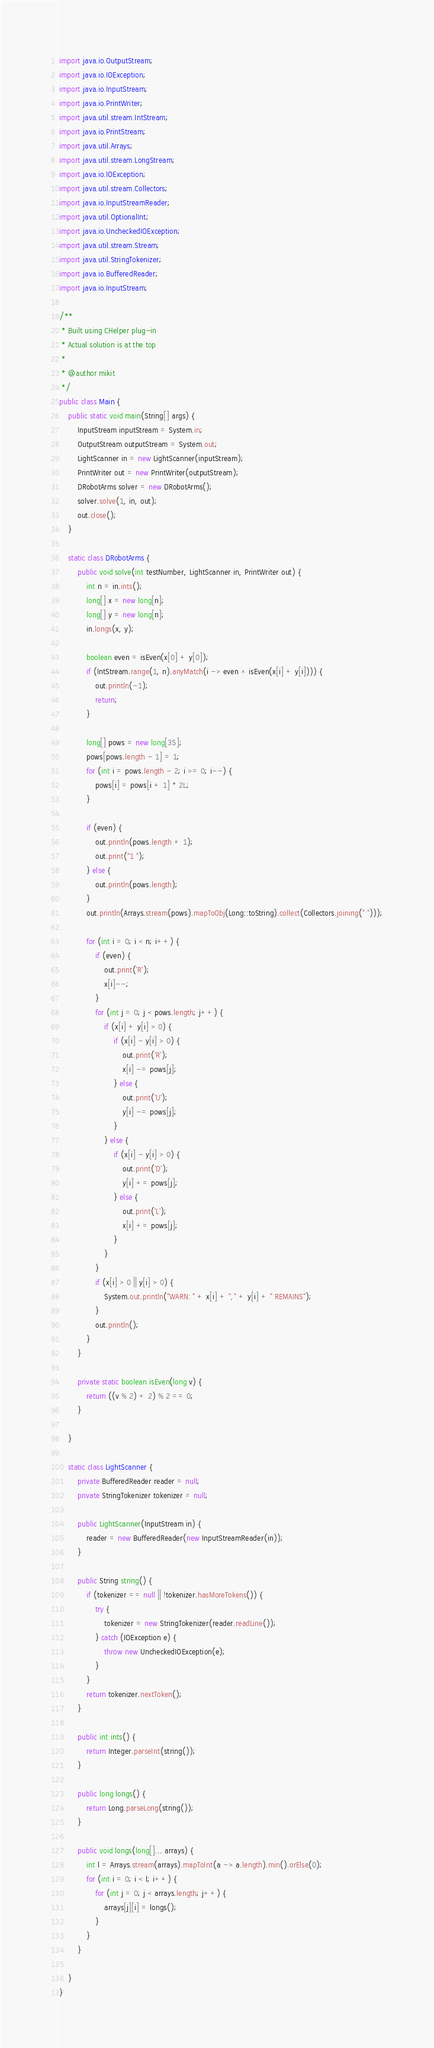<code> <loc_0><loc_0><loc_500><loc_500><_Java_>import java.io.OutputStream;
import java.io.IOException;
import java.io.InputStream;
import java.io.PrintWriter;
import java.util.stream.IntStream;
import java.io.PrintStream;
import java.util.Arrays;
import java.util.stream.LongStream;
import java.io.IOException;
import java.util.stream.Collectors;
import java.io.InputStreamReader;
import java.util.OptionalInt;
import java.io.UncheckedIOException;
import java.util.stream.Stream;
import java.util.StringTokenizer;
import java.io.BufferedReader;
import java.io.InputStream;

/**
 * Built using CHelper plug-in
 * Actual solution is at the top
 *
 * @author mikit
 */
public class Main {
    public static void main(String[] args) {
        InputStream inputStream = System.in;
        OutputStream outputStream = System.out;
        LightScanner in = new LightScanner(inputStream);
        PrintWriter out = new PrintWriter(outputStream);
        DRobotArms solver = new DRobotArms();
        solver.solve(1, in, out);
        out.close();
    }

    static class DRobotArms {
        public void solve(int testNumber, LightScanner in, PrintWriter out) {
            int n = in.ints();
            long[] x = new long[n];
            long[] y = new long[n];
            in.longs(x, y);

            boolean even = isEven(x[0] + y[0]);
            if (IntStream.range(1, n).anyMatch(i -> even ^ isEven(x[i] + y[i]))) {
                out.println(-1);
                return;
            }

            long[] pows = new long[35];
            pows[pows.length - 1] = 1;
            for (int i = pows.length - 2; i >= 0; i--) {
                pows[i] = pows[i + 1] * 2L;
            }

            if (even) {
                out.println(pows.length + 1);
                out.print("1 ");
            } else {
                out.println(pows.length);
            }
            out.println(Arrays.stream(pows).mapToObj(Long::toString).collect(Collectors.joining(" ")));

            for (int i = 0; i < n; i++) {
                if (even) {
                    out.print('R');
                    x[i]--;
                }
                for (int j = 0; j < pows.length; j++) {
                    if (x[i] + y[i] > 0) {
                        if (x[i] - y[i] > 0) {
                            out.print('R');
                            x[i] -= pows[j];
                        } else {
                            out.print('U');
                            y[i] -= pows[j];
                        }
                    } else {
                        if (x[i] - y[i] > 0) {
                            out.print('D');
                            y[i] += pows[j];
                        } else {
                            out.print('L');
                            x[i] += pows[j];
                        }
                    }
                }
                if (x[i] > 0 || y[i] > 0) {
                    System.out.println("WARN: " + x[i] + "," + y[i] + " REMAINS");
                }
                out.println();
            }
        }

        private static boolean isEven(long v) {
            return ((v % 2) + 2) % 2 == 0;
        }

    }

    static class LightScanner {
        private BufferedReader reader = null;
        private StringTokenizer tokenizer = null;

        public LightScanner(InputStream in) {
            reader = new BufferedReader(new InputStreamReader(in));
        }

        public String string() {
            if (tokenizer == null || !tokenizer.hasMoreTokens()) {
                try {
                    tokenizer = new StringTokenizer(reader.readLine());
                } catch (IOException e) {
                    throw new UncheckedIOException(e);
                }
            }
            return tokenizer.nextToken();
        }

        public int ints() {
            return Integer.parseInt(string());
        }

        public long longs() {
            return Long.parseLong(string());
        }

        public void longs(long[]... arrays) {
            int l = Arrays.stream(arrays).mapToInt(a -> a.length).min().orElse(0);
            for (int i = 0; i < l; i++) {
                for (int j = 0; j < arrays.length; j++) {
                    arrays[j][i] = longs();
                }
            }
        }

    }
}

</code> 